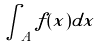Convert formula to latex. <formula><loc_0><loc_0><loc_500><loc_500>\int _ { A } f ( x ) d x</formula> 